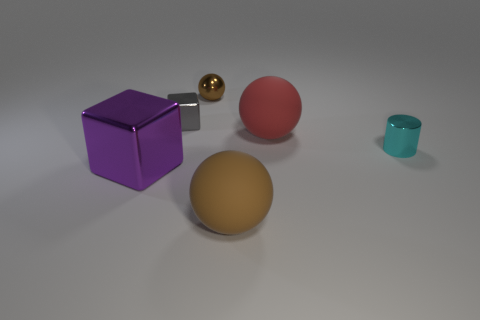Subtract all matte spheres. How many spheres are left? 1 Add 3 blocks. How many objects exist? 9 Subtract 1 cylinders. How many cylinders are left? 0 Subtract all purple cylinders. Subtract all yellow blocks. How many cylinders are left? 1 Subtract all cyan cylinders. How many gray blocks are left? 1 Subtract all tiny gray cubes. Subtract all matte objects. How many objects are left? 3 Add 6 brown rubber things. How many brown rubber things are left? 7 Add 4 tiny rubber blocks. How many tiny rubber blocks exist? 4 Subtract all brown balls. How many balls are left? 1 Subtract 0 green cylinders. How many objects are left? 6 